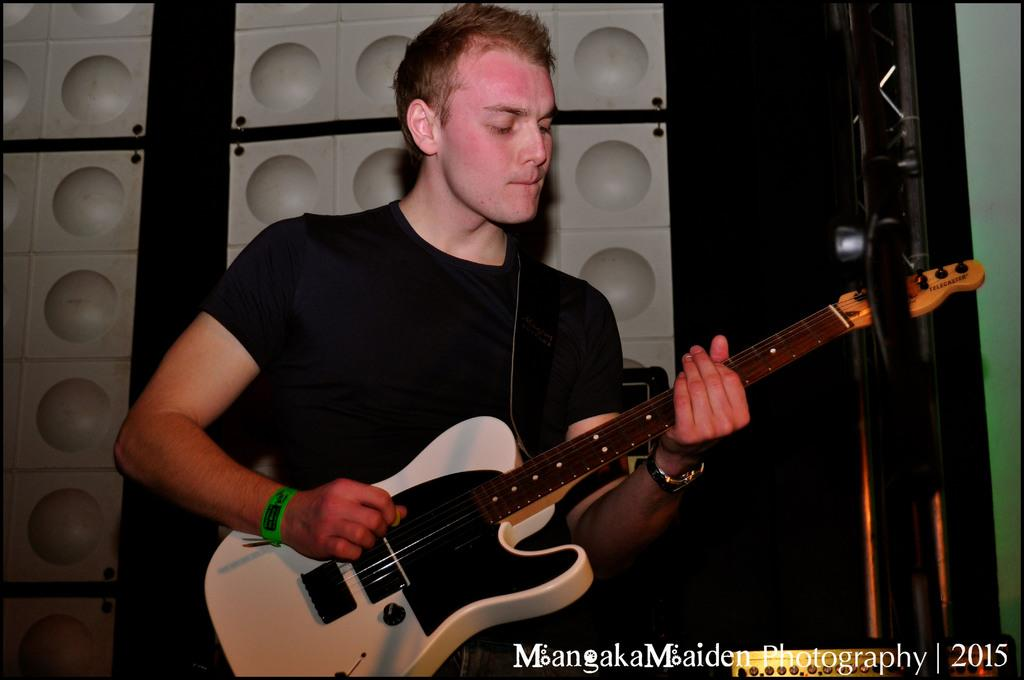What is the main activity being performed by the person in the image? The person is playing a guitar in the image. What additional information can be found at the bottom of the image? There is text written at the bottom of the image. What can be seen in the background of the image? There is a white surface in the background of the image. How many mice are hiding behind the white surface in the image? There are no mice present in the image; it only features a person playing a guitar and text at the bottom. 